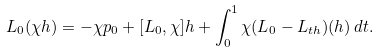Convert formula to latex. <formula><loc_0><loc_0><loc_500><loc_500>L _ { 0 } ( \chi h ) = - \chi p _ { 0 } + [ L _ { 0 } , \chi ] h + \int _ { 0 } ^ { 1 } \chi ( L _ { 0 } - L _ { t h } ) ( h ) \, d t .</formula> 